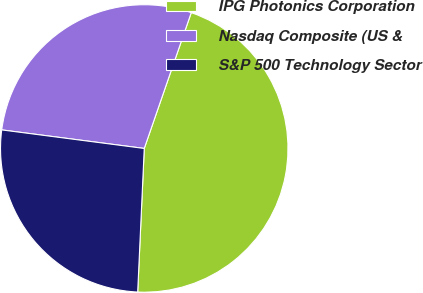<chart> <loc_0><loc_0><loc_500><loc_500><pie_chart><fcel>IPG Photonics Corporation<fcel>Nasdaq Composite (US &<fcel>S&P 500 Technology Sector<nl><fcel>45.42%<fcel>28.24%<fcel>26.33%<nl></chart> 